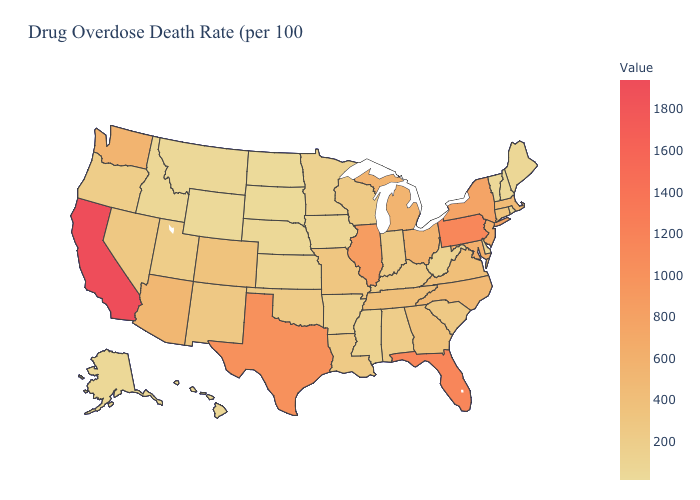Among the states that border Wyoming , does Montana have the lowest value?
Be succinct. No. Does Alaska have a lower value than Ohio?
Concise answer only. Yes. Does Tennessee have the lowest value in the South?
Quick response, please. No. Does California have the highest value in the West?
Concise answer only. Yes. Is the legend a continuous bar?
Give a very brief answer. Yes. Which states hav the highest value in the Northeast?
Answer briefly. Pennsylvania. Does Delaware have the lowest value in the South?
Quick response, please. Yes. Does Virginia have the lowest value in the South?
Give a very brief answer. No. 